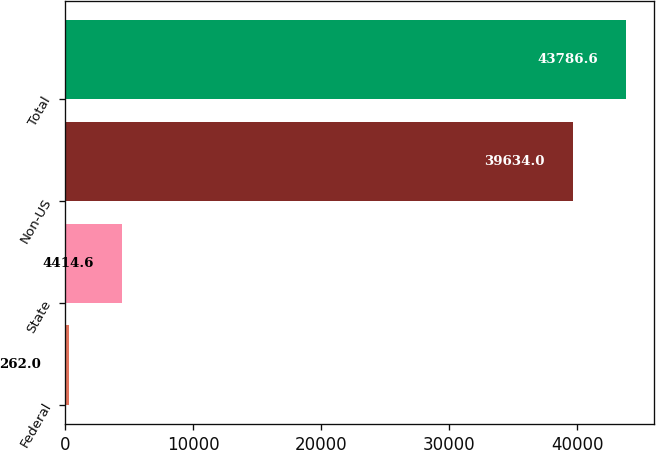Convert chart to OTSL. <chart><loc_0><loc_0><loc_500><loc_500><bar_chart><fcel>Federal<fcel>State<fcel>Non-US<fcel>Total<nl><fcel>262<fcel>4414.6<fcel>39634<fcel>43786.6<nl></chart> 